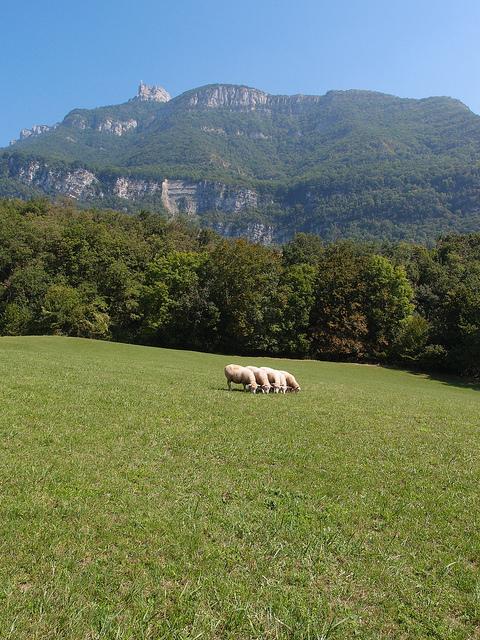How many farm animals?
Quick response, please. 5. How tall is the mountain?
Quick response, please. Very tall. How far in front of the trees are the sheep?
Quick response, please. 50 feet. 